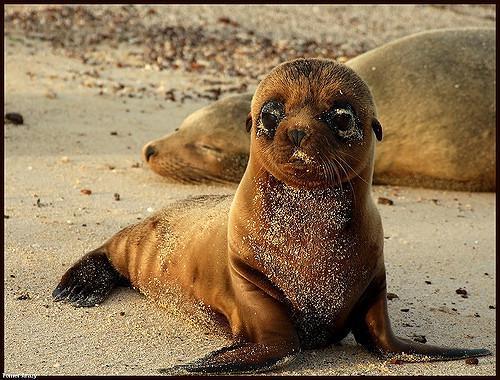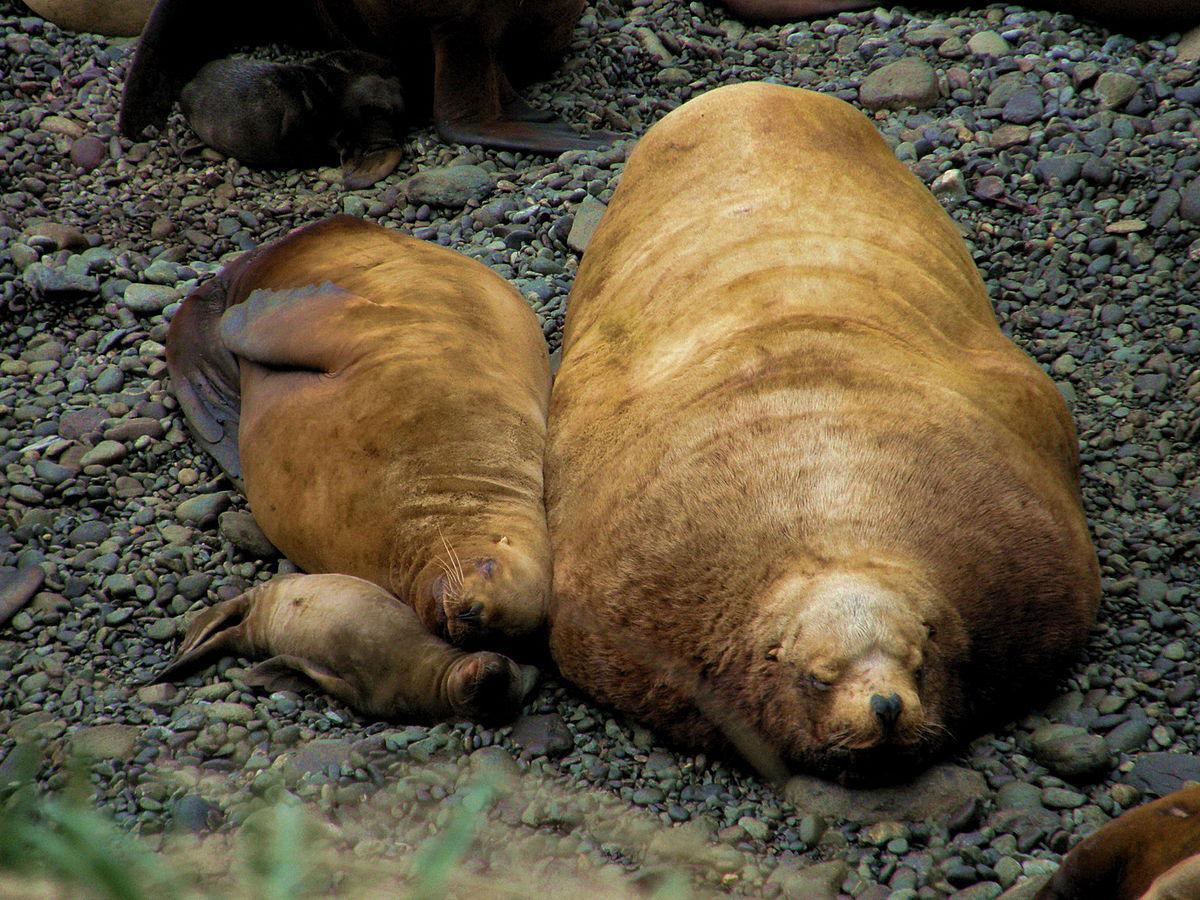The first image is the image on the left, the second image is the image on the right. For the images displayed, is the sentence "A juvenile sea lion can be seen near an adult sea lion." factually correct? Answer yes or no. Yes. 